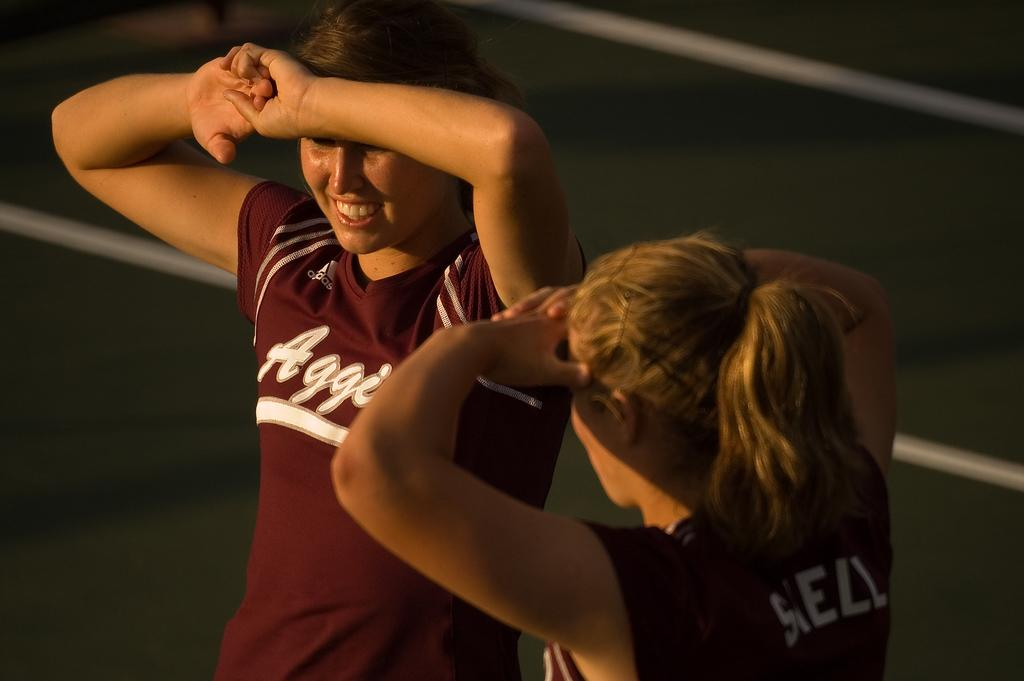<image>
Share a concise interpretation of the image provided. Two woman wear red sports jerseys for a team starting with "Aggi". 